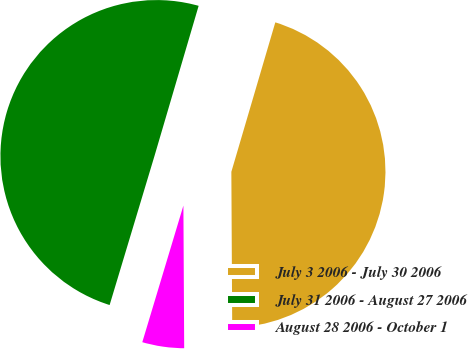<chart> <loc_0><loc_0><loc_500><loc_500><pie_chart><fcel>July 3 2006 - July 30 2006<fcel>July 31 2006 - August 27 2006<fcel>August 28 2006 - October 1<nl><fcel>45.36%<fcel>49.9%<fcel>4.74%<nl></chart> 